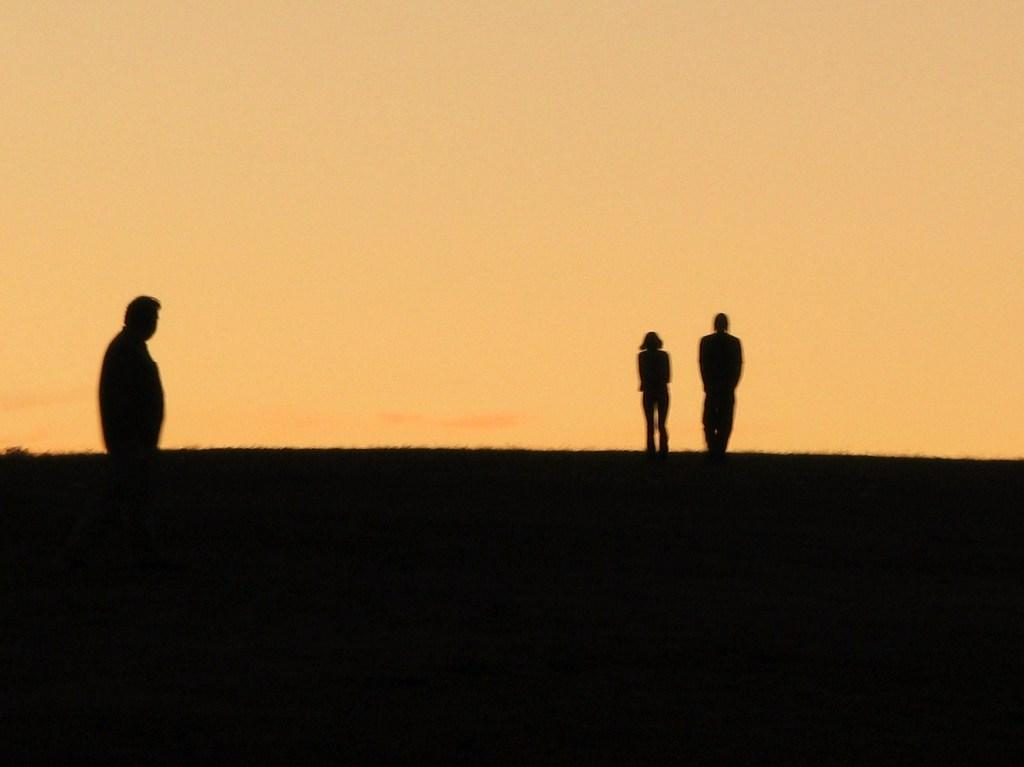How many people are in the image? There are three persons standing in the image. What is the overall appearance of the image? The image has a dark appearance. What can be seen in the background of the image? There is a sky visible in the background of the image. What type of whistle can be heard in the image? There is no whistle present in the image, and therefore no sound can be heard. 